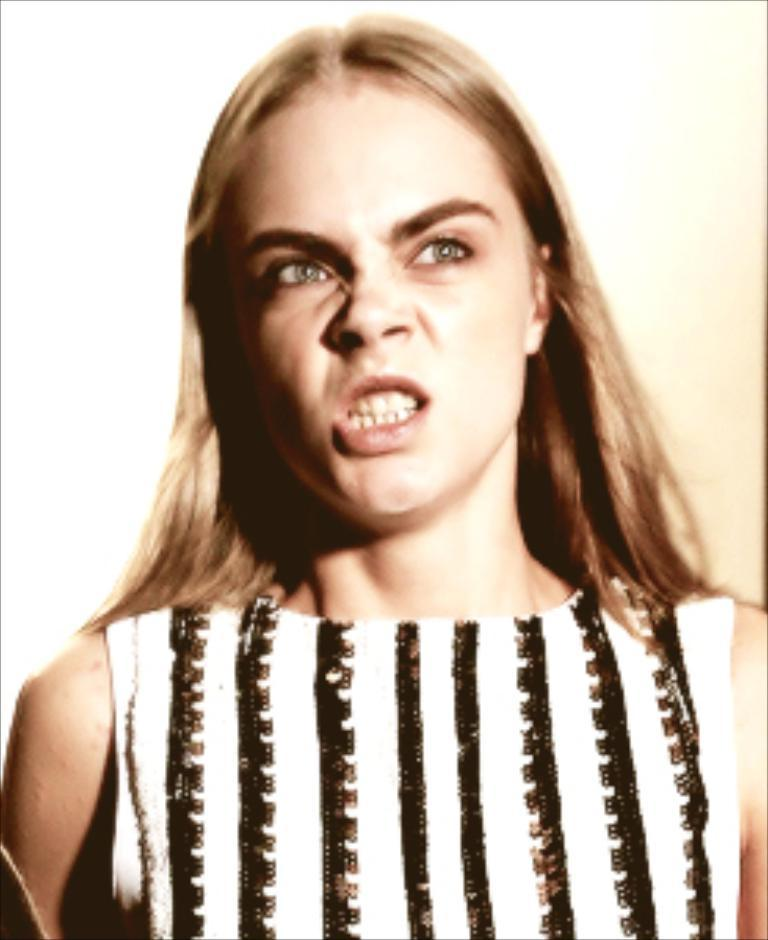Who is present in the image? There is a woman in the image. What type of silk is the woman wearing in the image? There is no mention of silk or any specific clothing in the image, so it cannot be determined what the woman might be wearing. 